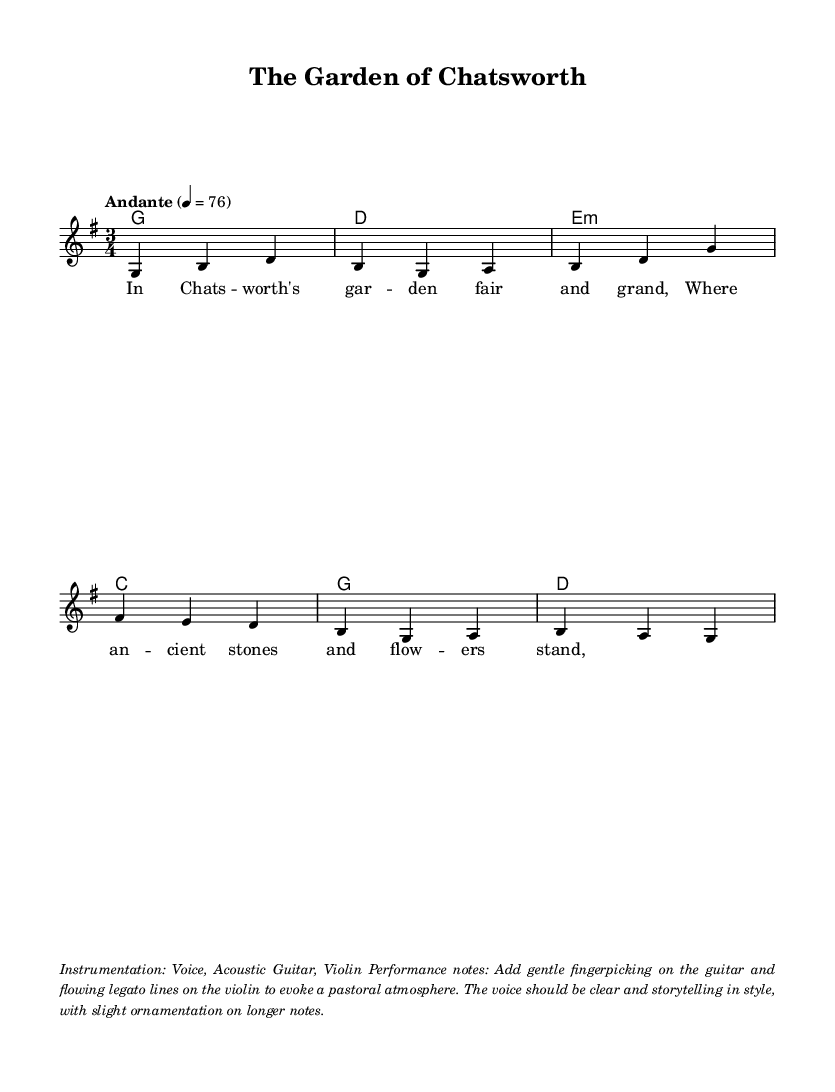What is the key signature of this music? The key signature is G major, which has one sharp (F#).
Answer: G major What is the time signature of this music? The time signature is 3/4, indicating three beats per measure.
Answer: 3/4 What is the tempo marking of this music? The tempo marking is "Andante," which suggests a moderately slow pace.
Answer: Andante What instruments are indicated for this piece? The instrumentation includes Voice, Acoustic Guitar, and Violin, which are typical for folk music.
Answer: Voice, Acoustic Guitar, Violin What kind of atmosphere should the performance evoke? The performance notes suggest a pastoral atmosphere, achieved with gentle fingerpicking and flowing legato lines.
Answer: Pastoral atmosphere What is the first line of the lyrics? The first line of the lyrics as indicated in the sheet music is "In Chats -- worth's gar -- den fair and grand."
Answer: In Chats -- worth's gar -- den fair and grand 